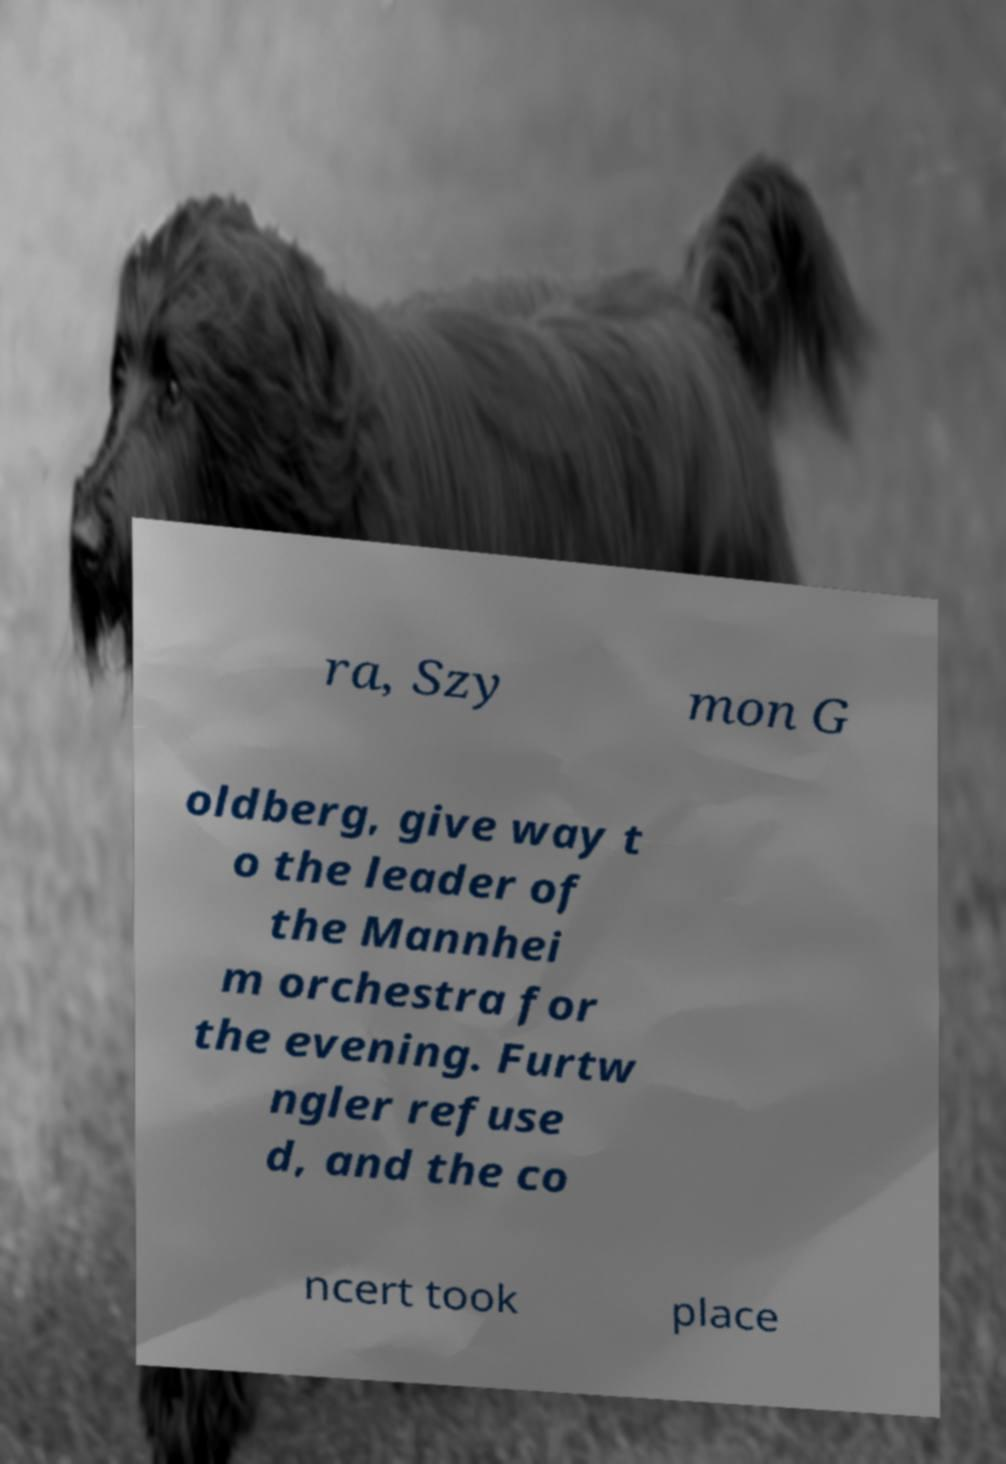Please identify and transcribe the text found in this image. ra, Szy mon G oldberg, give way t o the leader of the Mannhei m orchestra for the evening. Furtw ngler refuse d, and the co ncert took place 